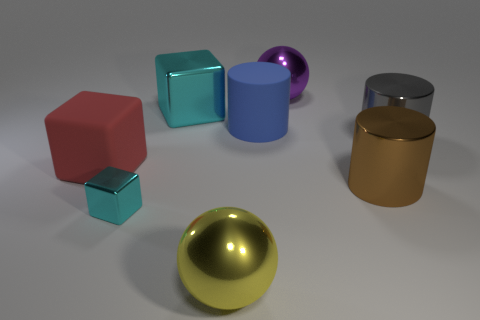What size is the cyan thing that is in front of the big rubber cube?
Give a very brief answer. Small. There is another cyan block that is made of the same material as the big cyan block; what size is it?
Your answer should be compact. Small. Are there fewer tiny cyan shiny objects than blocks?
Your answer should be compact. Yes. There is a blue thing that is the same size as the purple thing; what is its material?
Provide a succinct answer. Rubber. Is the number of tiny gray matte spheres greater than the number of brown shiny things?
Your answer should be compact. No. How many other things are the same color as the small thing?
Your response must be concise. 1. How many big matte objects are left of the blue rubber object and to the right of the large red matte thing?
Your response must be concise. 0. Are there more metal cylinders behind the big brown metallic thing than large gray things behind the large cyan cube?
Ensure brevity in your answer.  Yes. What material is the big cube that is in front of the matte cylinder?
Provide a short and direct response. Rubber. Is the shape of the purple object the same as the yellow metal object to the left of the big purple metallic ball?
Provide a succinct answer. Yes. 